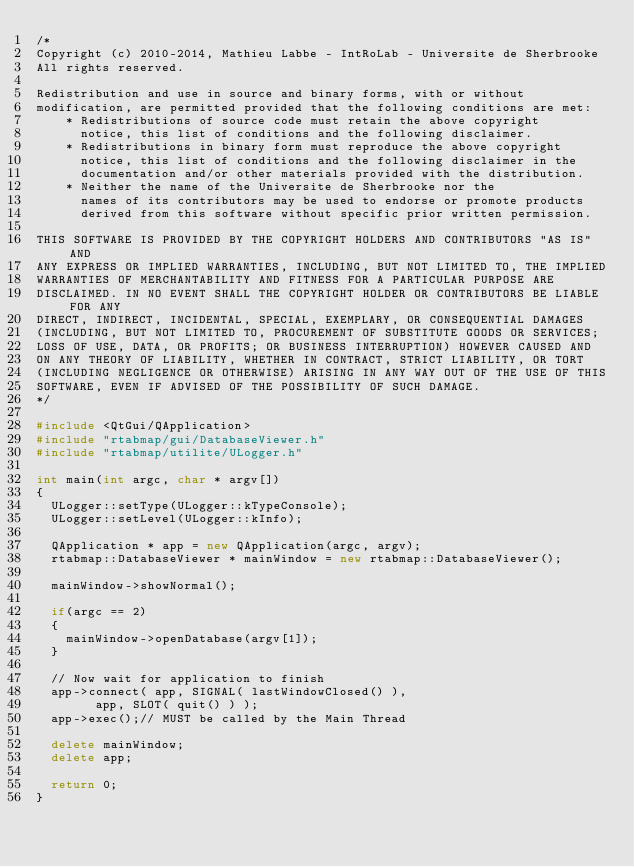Convert code to text. <code><loc_0><loc_0><loc_500><loc_500><_C++_>/*
Copyright (c) 2010-2014, Mathieu Labbe - IntRoLab - Universite de Sherbrooke
All rights reserved.

Redistribution and use in source and binary forms, with or without
modification, are permitted provided that the following conditions are met:
    * Redistributions of source code must retain the above copyright
      notice, this list of conditions and the following disclaimer.
    * Redistributions in binary form must reproduce the above copyright
      notice, this list of conditions and the following disclaimer in the
      documentation and/or other materials provided with the distribution.
    * Neither the name of the Universite de Sherbrooke nor the
      names of its contributors may be used to endorse or promote products
      derived from this software without specific prior written permission.

THIS SOFTWARE IS PROVIDED BY THE COPYRIGHT HOLDERS AND CONTRIBUTORS "AS IS" AND
ANY EXPRESS OR IMPLIED WARRANTIES, INCLUDING, BUT NOT LIMITED TO, THE IMPLIED
WARRANTIES OF MERCHANTABILITY AND FITNESS FOR A PARTICULAR PURPOSE ARE
DISCLAIMED. IN NO EVENT SHALL THE COPYRIGHT HOLDER OR CONTRIBUTORS BE LIABLE FOR ANY
DIRECT, INDIRECT, INCIDENTAL, SPECIAL, EXEMPLARY, OR CONSEQUENTIAL DAMAGES
(INCLUDING, BUT NOT LIMITED TO, PROCUREMENT OF SUBSTITUTE GOODS OR SERVICES;
LOSS OF USE, DATA, OR PROFITS; OR BUSINESS INTERRUPTION) HOWEVER CAUSED AND
ON ANY THEORY OF LIABILITY, WHETHER IN CONTRACT, STRICT LIABILITY, OR TORT
(INCLUDING NEGLIGENCE OR OTHERWISE) ARISING IN ANY WAY OUT OF THE USE OF THIS
SOFTWARE, EVEN IF ADVISED OF THE POSSIBILITY OF SUCH DAMAGE.
*/

#include <QtGui/QApplication>
#include "rtabmap/gui/DatabaseViewer.h"
#include "rtabmap/utilite/ULogger.h"

int main(int argc, char * argv[])
{
	ULogger::setType(ULogger::kTypeConsole);
	ULogger::setLevel(ULogger::kInfo);

	QApplication * app = new QApplication(argc, argv);
	rtabmap::DatabaseViewer * mainWindow = new rtabmap::DatabaseViewer();

	mainWindow->showNormal();

	if(argc == 2)
	{
		mainWindow->openDatabase(argv[1]);
	}

	// Now wait for application to finish
	app->connect( app, SIGNAL( lastWindowClosed() ),
				app, SLOT( quit() ) );
	app->exec();// MUST be called by the Main Thread

	delete mainWindow;
	delete app;

	return 0;
}
</code> 